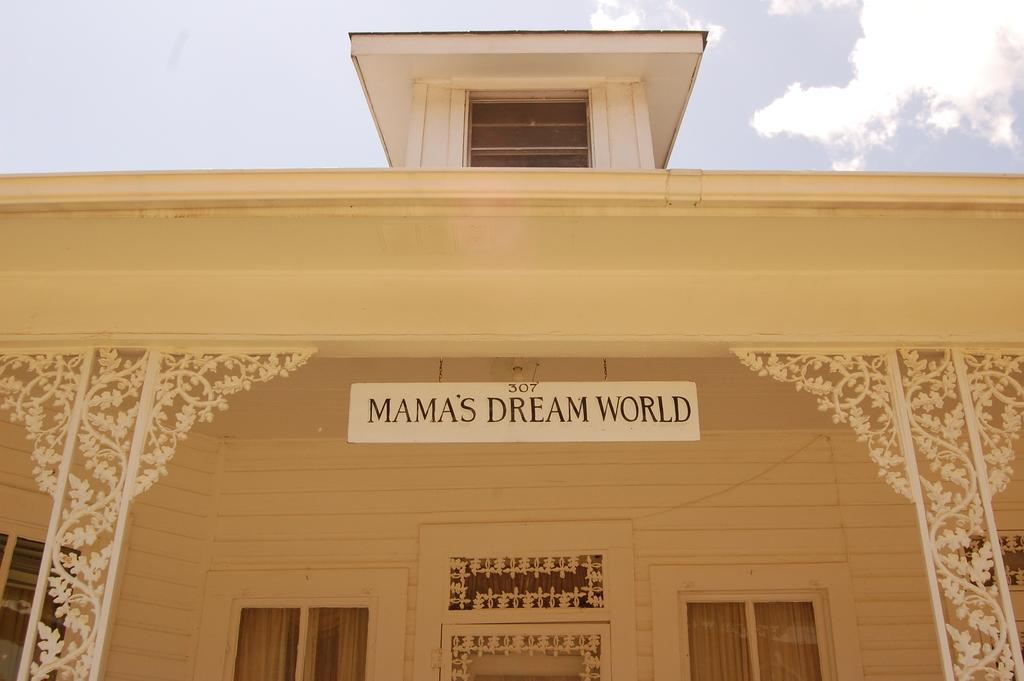What type of structure is in the image? There is a building in the image. What feature can be seen on the building? The building has windows. What is inside the windows? The windows have curtains. What is on top of the building? There is a whiteboard on top of the building. How would you describe the weather based on the image? The sky is cloudy in the image. What type of animal is the minister riding in the image? There is no animal or minister present in the image; it features a building with windows, curtains, a whiteboard, and a cloudy sky. 